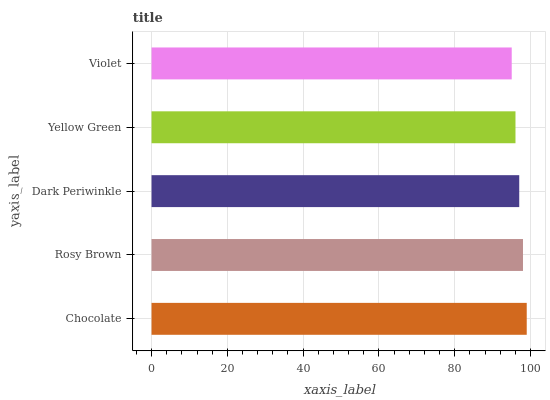Is Violet the minimum?
Answer yes or no. Yes. Is Chocolate the maximum?
Answer yes or no. Yes. Is Rosy Brown the minimum?
Answer yes or no. No. Is Rosy Brown the maximum?
Answer yes or no. No. Is Chocolate greater than Rosy Brown?
Answer yes or no. Yes. Is Rosy Brown less than Chocolate?
Answer yes or no. Yes. Is Rosy Brown greater than Chocolate?
Answer yes or no. No. Is Chocolate less than Rosy Brown?
Answer yes or no. No. Is Dark Periwinkle the high median?
Answer yes or no. Yes. Is Dark Periwinkle the low median?
Answer yes or no. Yes. Is Chocolate the high median?
Answer yes or no. No. Is Rosy Brown the low median?
Answer yes or no. No. 